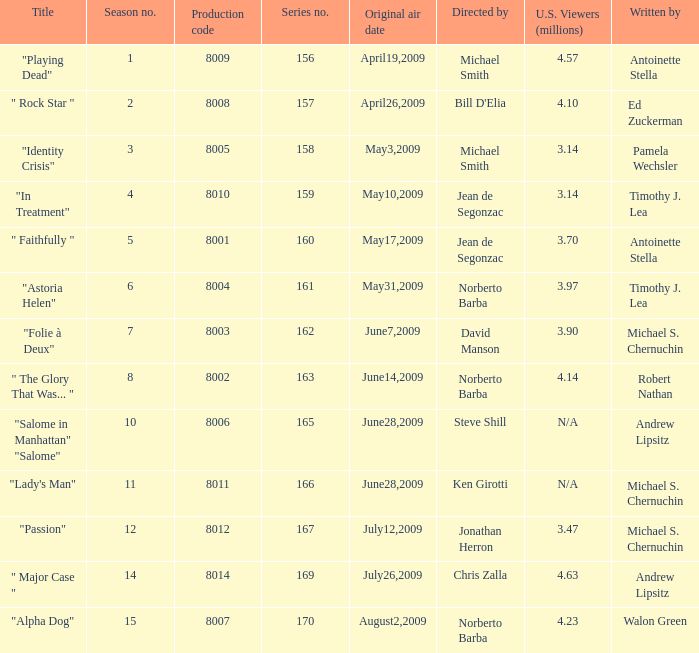Which is the biggest production code? 8014.0. 